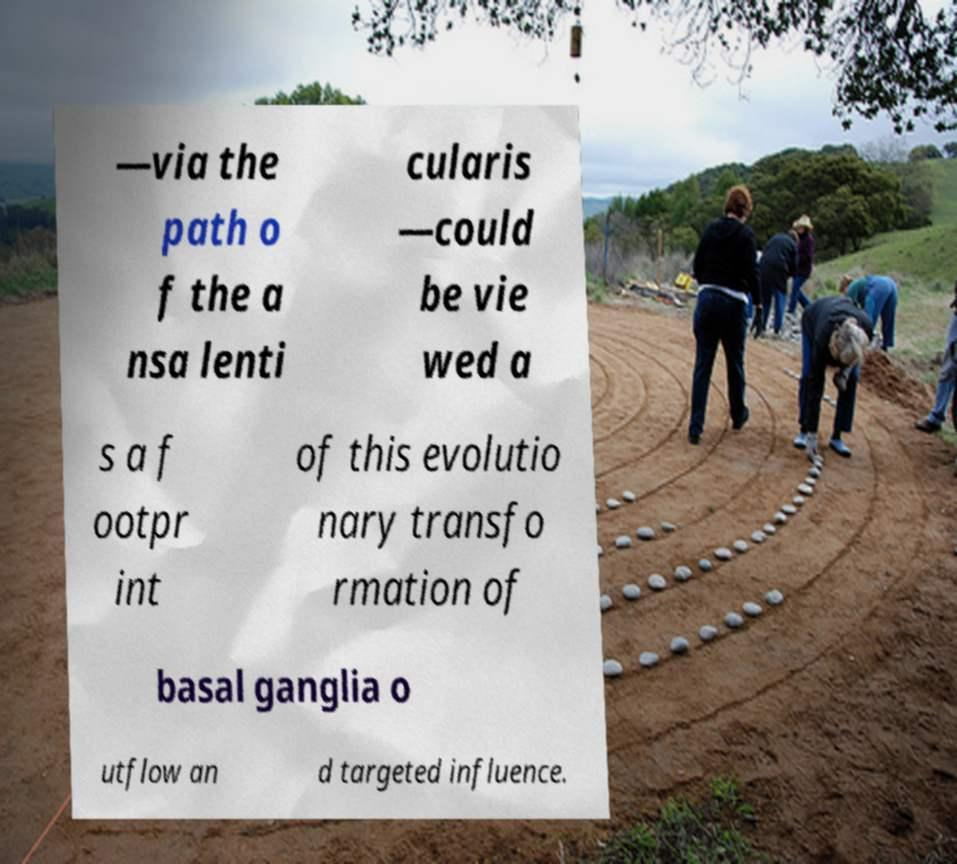For documentation purposes, I need the text within this image transcribed. Could you provide that? —via the path o f the a nsa lenti cularis —could be vie wed a s a f ootpr int of this evolutio nary transfo rmation of basal ganglia o utflow an d targeted influence. 